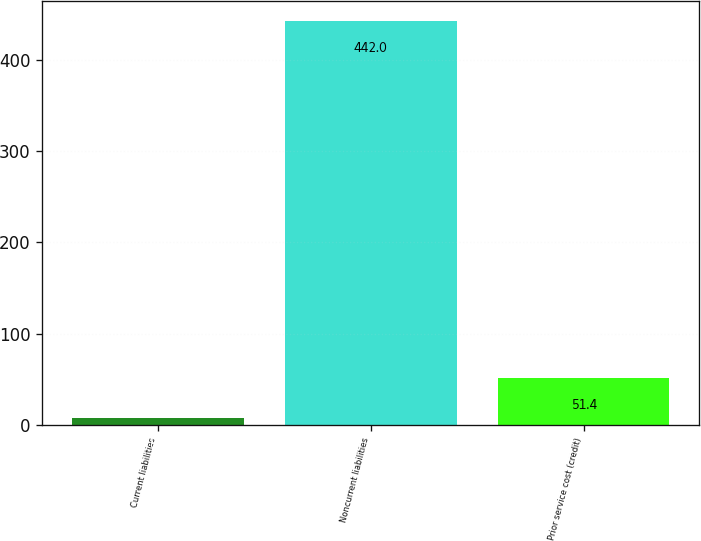Convert chart. <chart><loc_0><loc_0><loc_500><loc_500><bar_chart><fcel>Current liabilities<fcel>Noncurrent liabilities<fcel>Prior service cost (credit)<nl><fcel>8<fcel>442<fcel>51.4<nl></chart> 